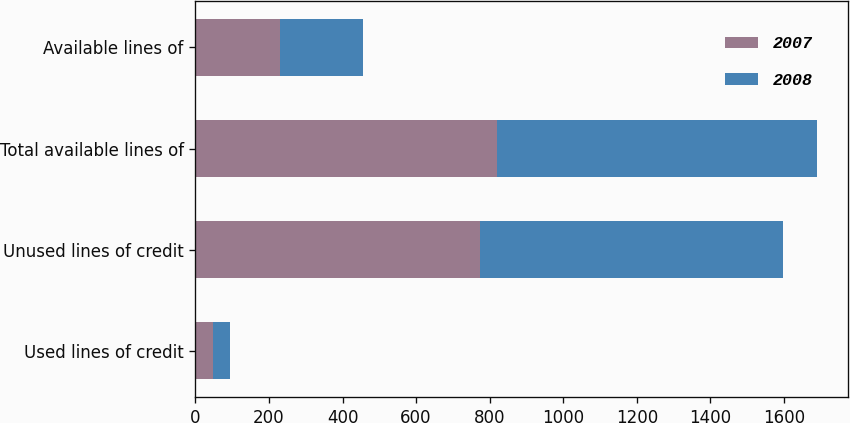Convert chart. <chart><loc_0><loc_0><loc_500><loc_500><stacked_bar_chart><ecel><fcel>Used lines of credit<fcel>Unused lines of credit<fcel>Total available lines of<fcel>Available lines of<nl><fcel>2007<fcel>46.7<fcel>773.4<fcel>820.1<fcel>231.3<nl><fcel>2008<fcel>46.4<fcel>823.8<fcel>870.2<fcel>224.2<nl></chart> 